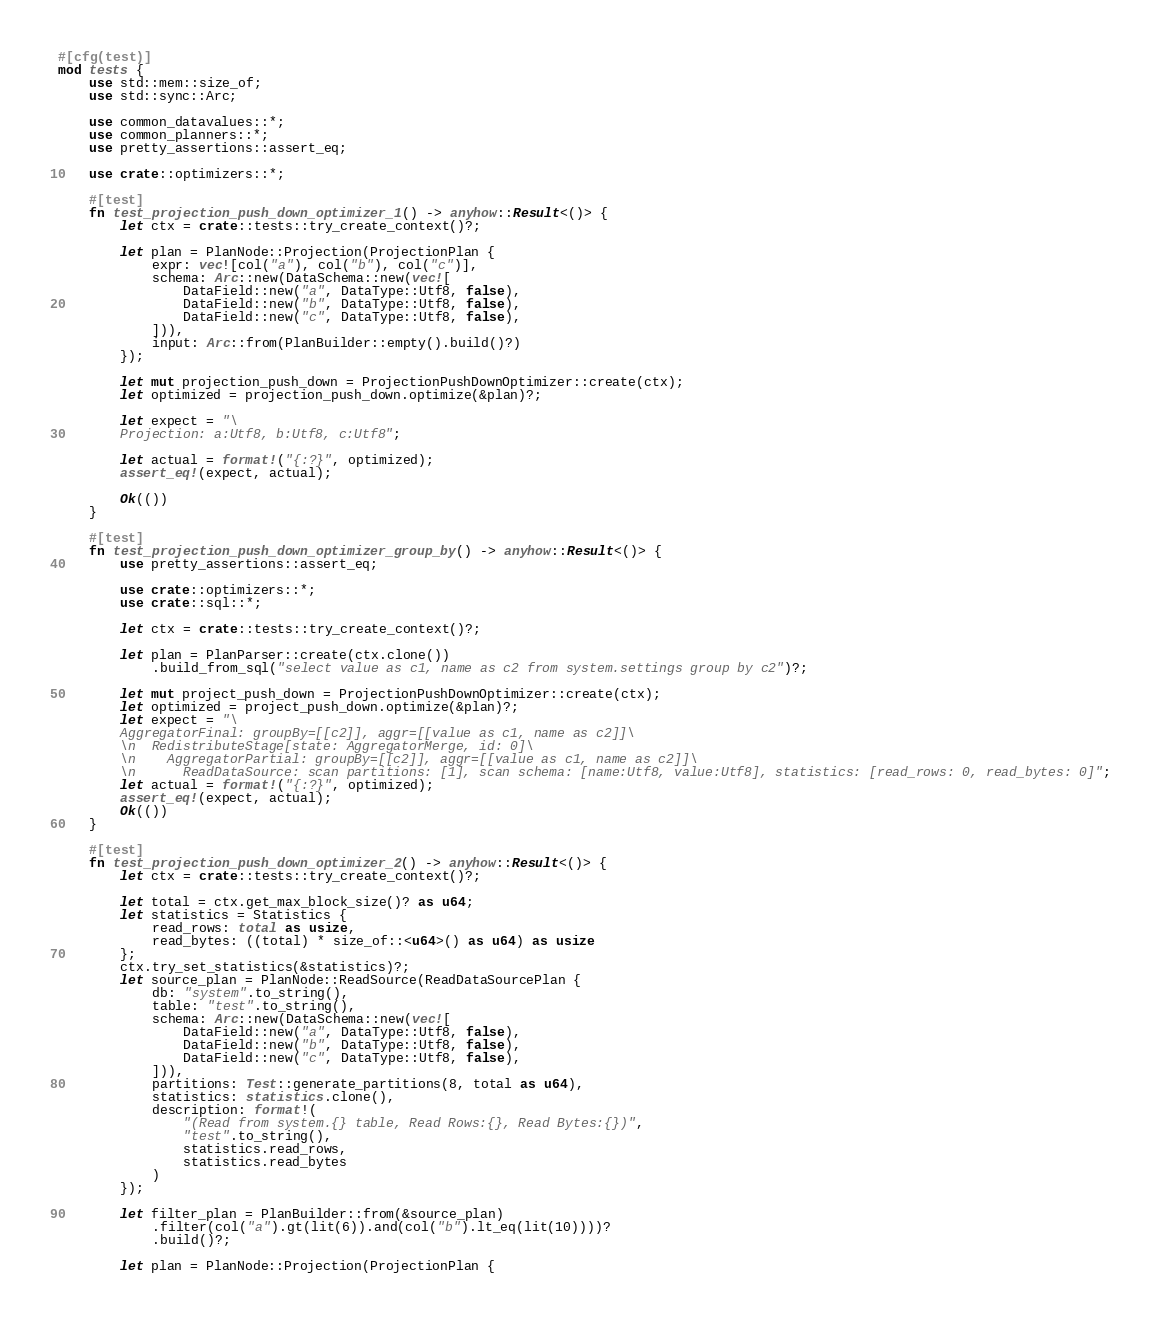Convert code to text. <code><loc_0><loc_0><loc_500><loc_500><_Rust_>#[cfg(test)]
mod tests {
    use std::mem::size_of;
    use std::sync::Arc;

    use common_datavalues::*;
    use common_planners::*;
    use pretty_assertions::assert_eq;

    use crate::optimizers::*;

    #[test]
    fn test_projection_push_down_optimizer_1() -> anyhow::Result<()> {
        let ctx = crate::tests::try_create_context()?;

        let plan = PlanNode::Projection(ProjectionPlan {
            expr: vec![col("a"), col("b"), col("c")],
            schema: Arc::new(DataSchema::new(vec![
                DataField::new("a", DataType::Utf8, false),
                DataField::new("b", DataType::Utf8, false),
                DataField::new("c", DataType::Utf8, false),
            ])),
            input: Arc::from(PlanBuilder::empty().build()?)
        });

        let mut projection_push_down = ProjectionPushDownOptimizer::create(ctx);
        let optimized = projection_push_down.optimize(&plan)?;

        let expect = "\
        Projection: a:Utf8, b:Utf8, c:Utf8";

        let actual = format!("{:?}", optimized);
        assert_eq!(expect, actual);

        Ok(())
    }

    #[test]
    fn test_projection_push_down_optimizer_group_by() -> anyhow::Result<()> {
        use pretty_assertions::assert_eq;

        use crate::optimizers::*;
        use crate::sql::*;

        let ctx = crate::tests::try_create_context()?;

        let plan = PlanParser::create(ctx.clone())
            .build_from_sql("select value as c1, name as c2 from system.settings group by c2")?;

        let mut project_push_down = ProjectionPushDownOptimizer::create(ctx);
        let optimized = project_push_down.optimize(&plan)?;
        let expect = "\
        AggregatorFinal: groupBy=[[c2]], aggr=[[value as c1, name as c2]]\
        \n  RedistributeStage[state: AggregatorMerge, id: 0]\
        \n    AggregatorPartial: groupBy=[[c2]], aggr=[[value as c1, name as c2]]\
        \n      ReadDataSource: scan partitions: [1], scan schema: [name:Utf8, value:Utf8], statistics: [read_rows: 0, read_bytes: 0]";
        let actual = format!("{:?}", optimized);
        assert_eq!(expect, actual);
        Ok(())
    }

    #[test]
    fn test_projection_push_down_optimizer_2() -> anyhow::Result<()> {
        let ctx = crate::tests::try_create_context()?;

        let total = ctx.get_max_block_size()? as u64;
        let statistics = Statistics {
            read_rows: total as usize,
            read_bytes: ((total) * size_of::<u64>() as u64) as usize
        };
        ctx.try_set_statistics(&statistics)?;
        let source_plan = PlanNode::ReadSource(ReadDataSourcePlan {
            db: "system".to_string(),
            table: "test".to_string(),
            schema: Arc::new(DataSchema::new(vec![
                DataField::new("a", DataType::Utf8, false),
                DataField::new("b", DataType::Utf8, false),
                DataField::new("c", DataType::Utf8, false),
            ])),
            partitions: Test::generate_partitions(8, total as u64),
            statistics: statistics.clone(),
            description: format!(
                "(Read from system.{} table, Read Rows:{}, Read Bytes:{})",
                "test".to_string(),
                statistics.read_rows,
                statistics.read_bytes
            )
        });

        let filter_plan = PlanBuilder::from(&source_plan)
            .filter(col("a").gt(lit(6)).and(col("b").lt_eq(lit(10))))?
            .build()?;

        let plan = PlanNode::Projection(ProjectionPlan {</code> 